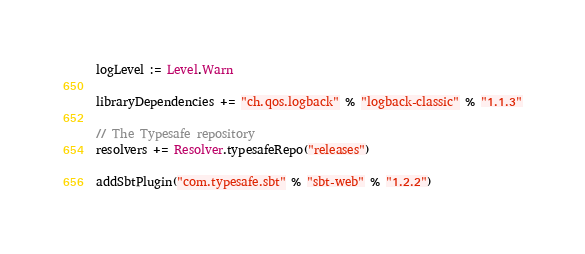Convert code to text. <code><loc_0><loc_0><loc_500><loc_500><_Scala_>logLevel := Level.Warn

libraryDependencies += "ch.qos.logback" % "logback-classic" % "1.1.3"

// The Typesafe repository
resolvers += Resolver.typesafeRepo("releases")

addSbtPlugin("com.typesafe.sbt" % "sbt-web" % "1.2.2")
</code> 